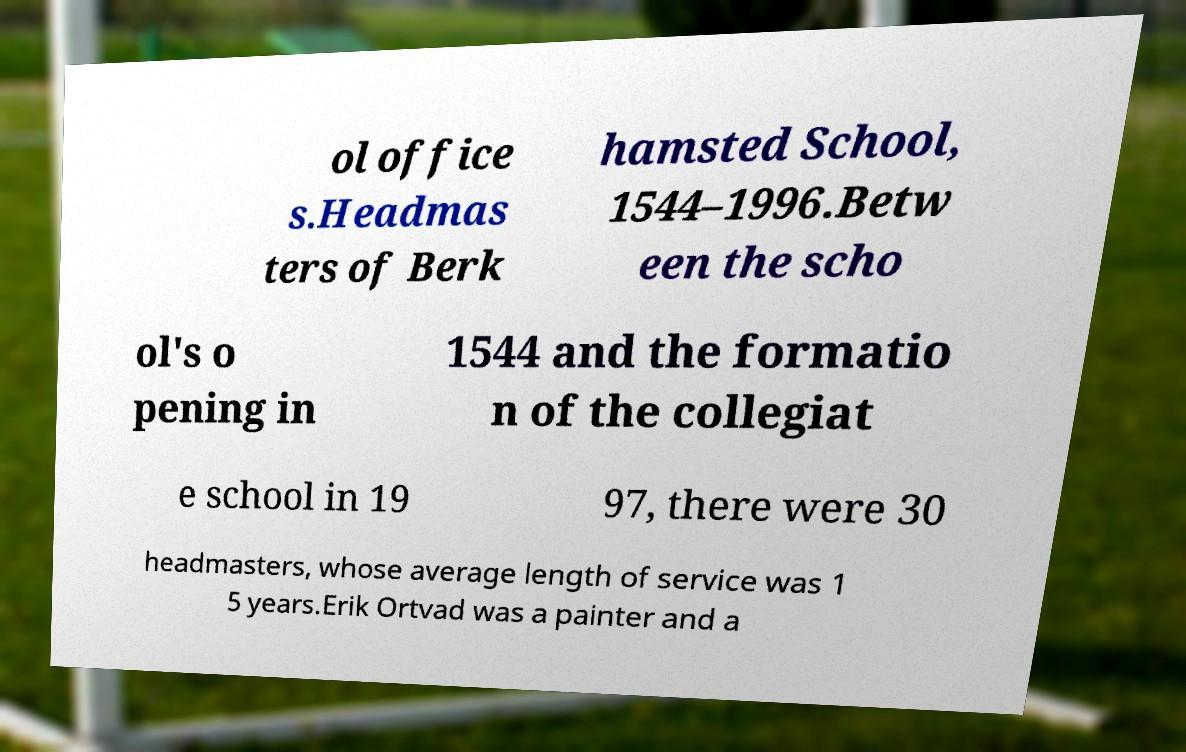Please read and relay the text visible in this image. What does it say? ol office s.Headmas ters of Berk hamsted School, 1544–1996.Betw een the scho ol's o pening in 1544 and the formatio n of the collegiat e school in 19 97, there were 30 headmasters, whose average length of service was 1 5 years.Erik Ortvad was a painter and a 